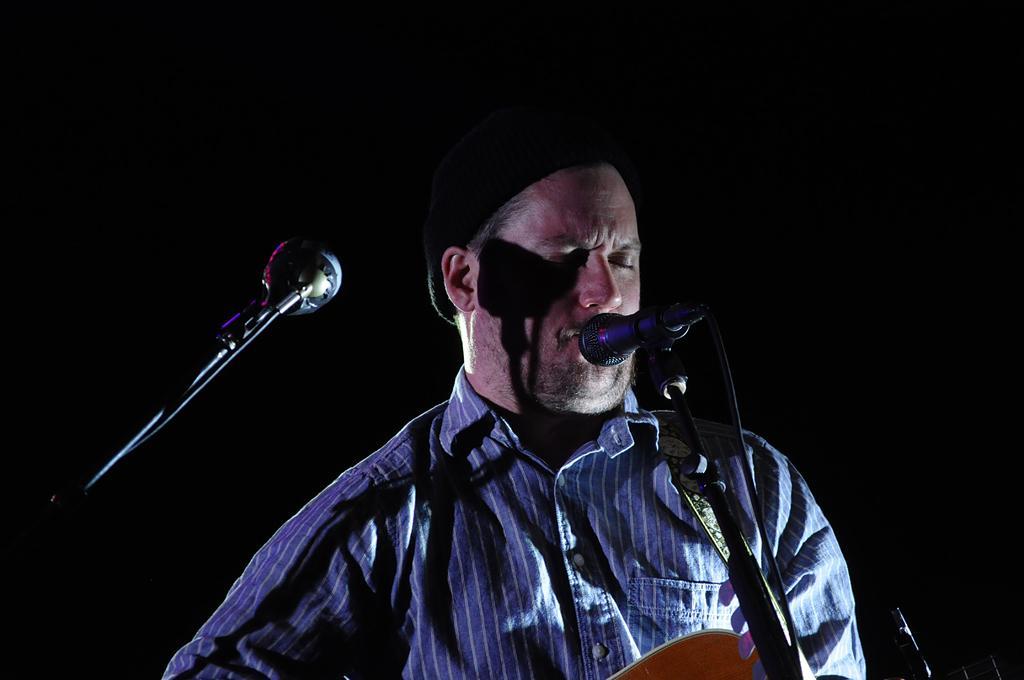Could you give a brief overview of what you see in this image? Man in this picture who is wearing blue shirt is holding musical instrument in his hands and he is singing on microphone which is placed in front of him. Beside him, we ever see another microphone and this picture is taken in dark. 